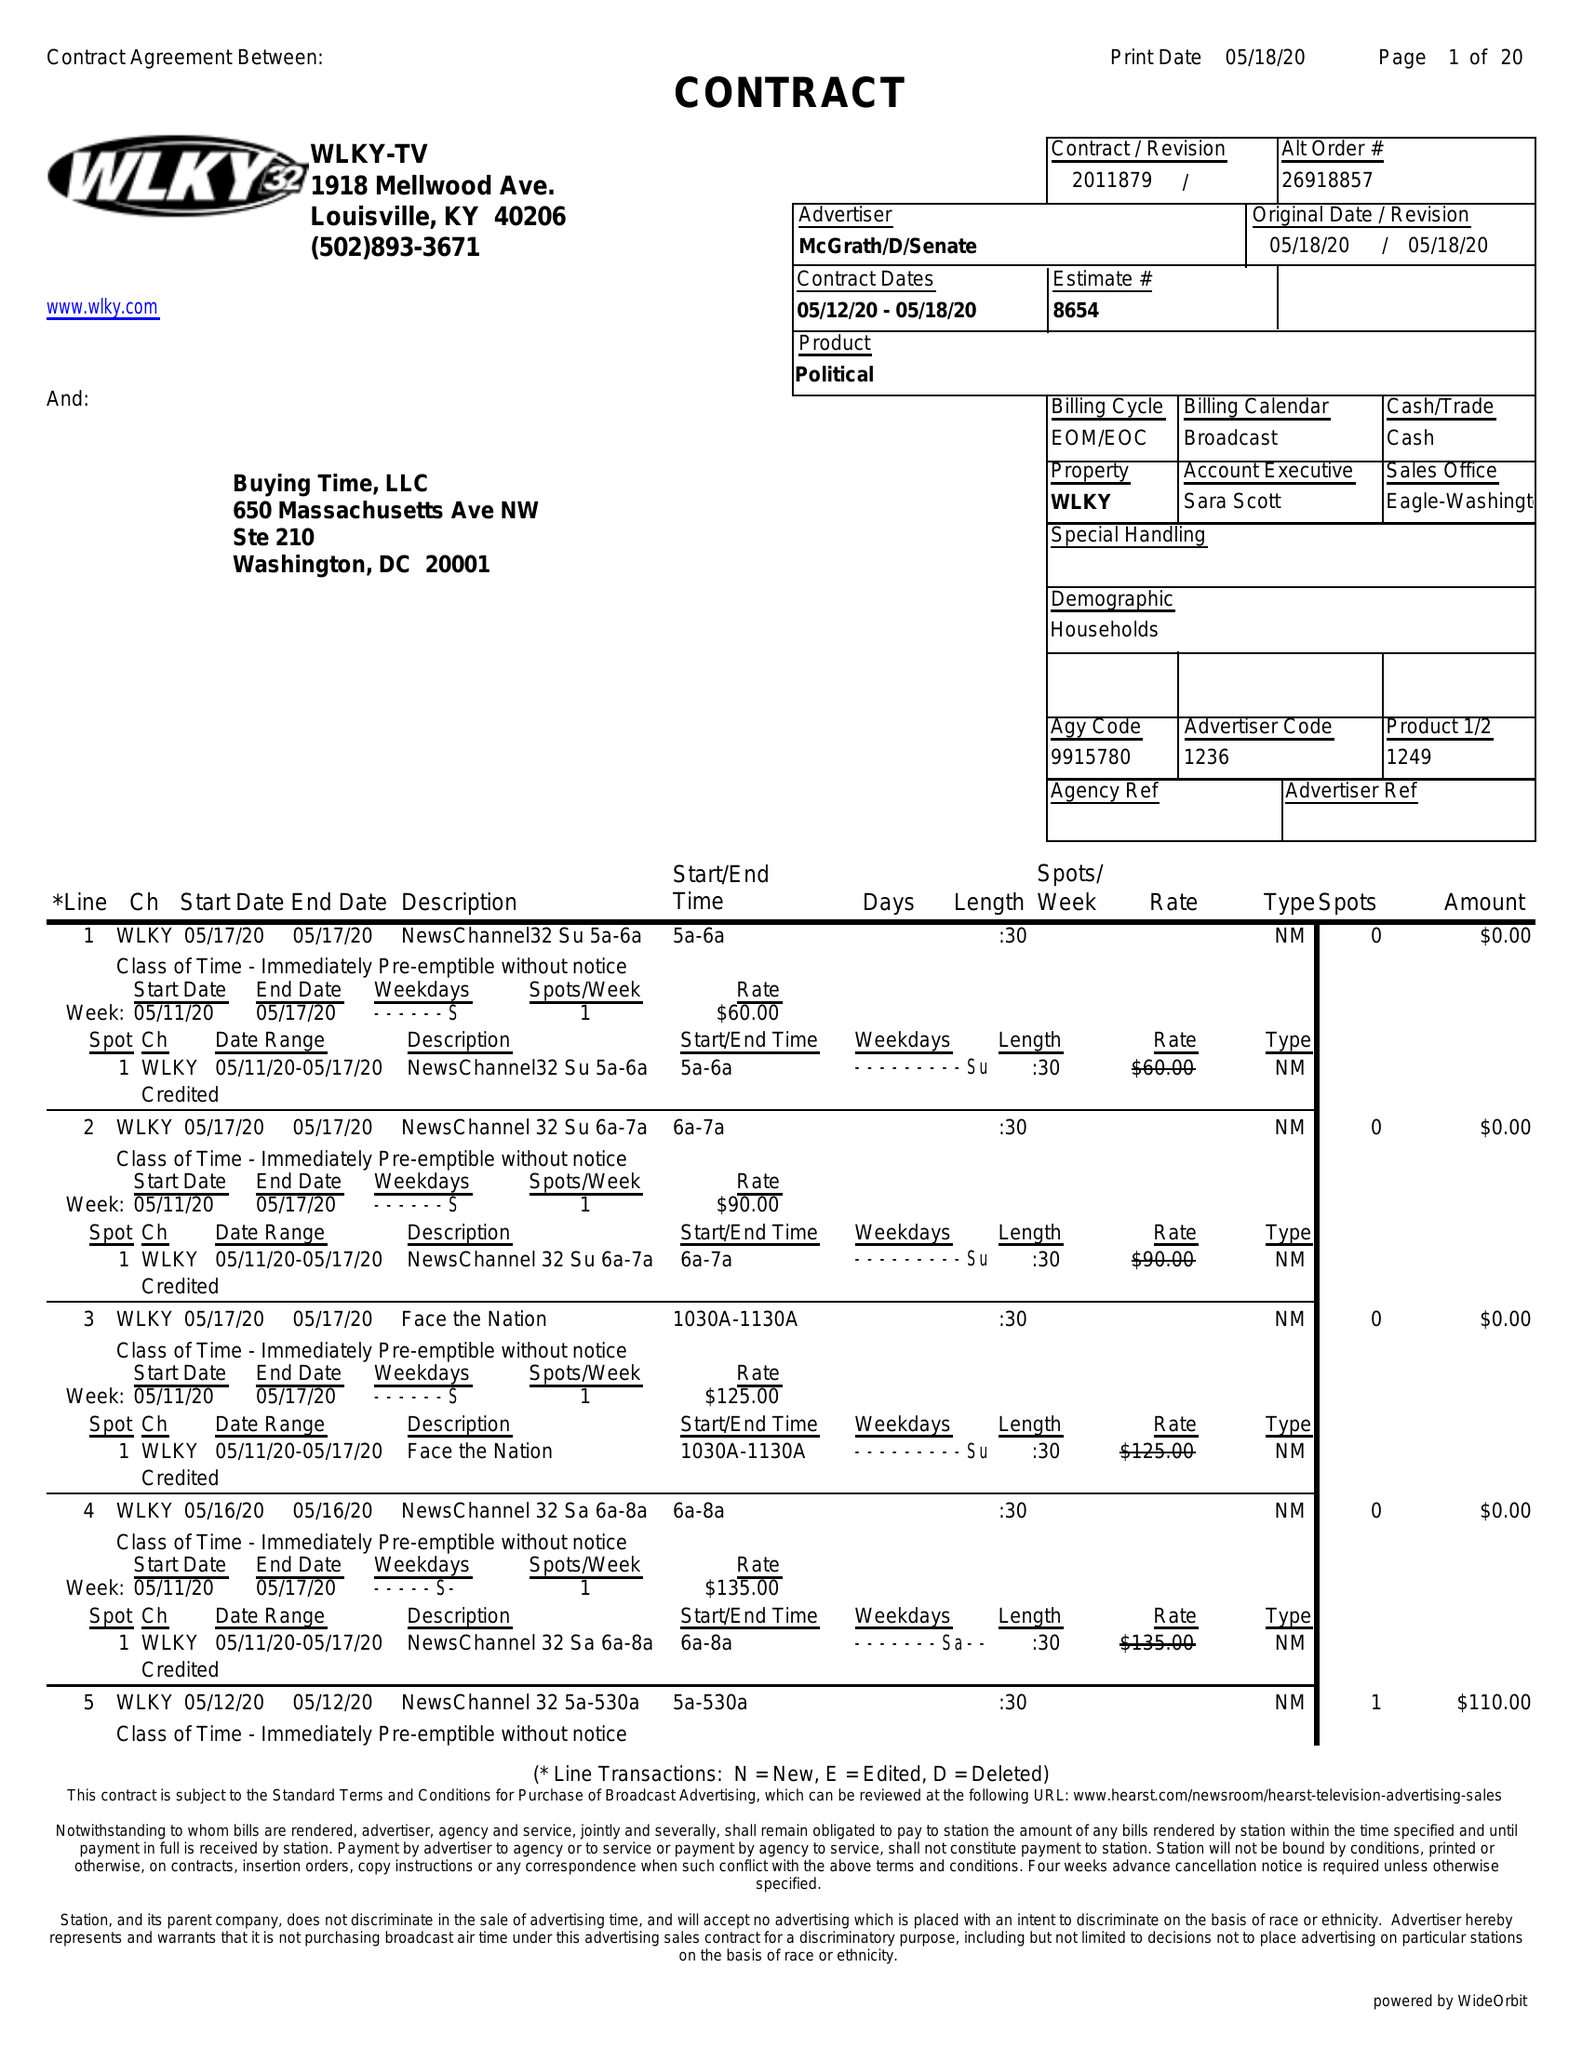What is the value for the flight_to?
Answer the question using a single word or phrase. 05/18/20 